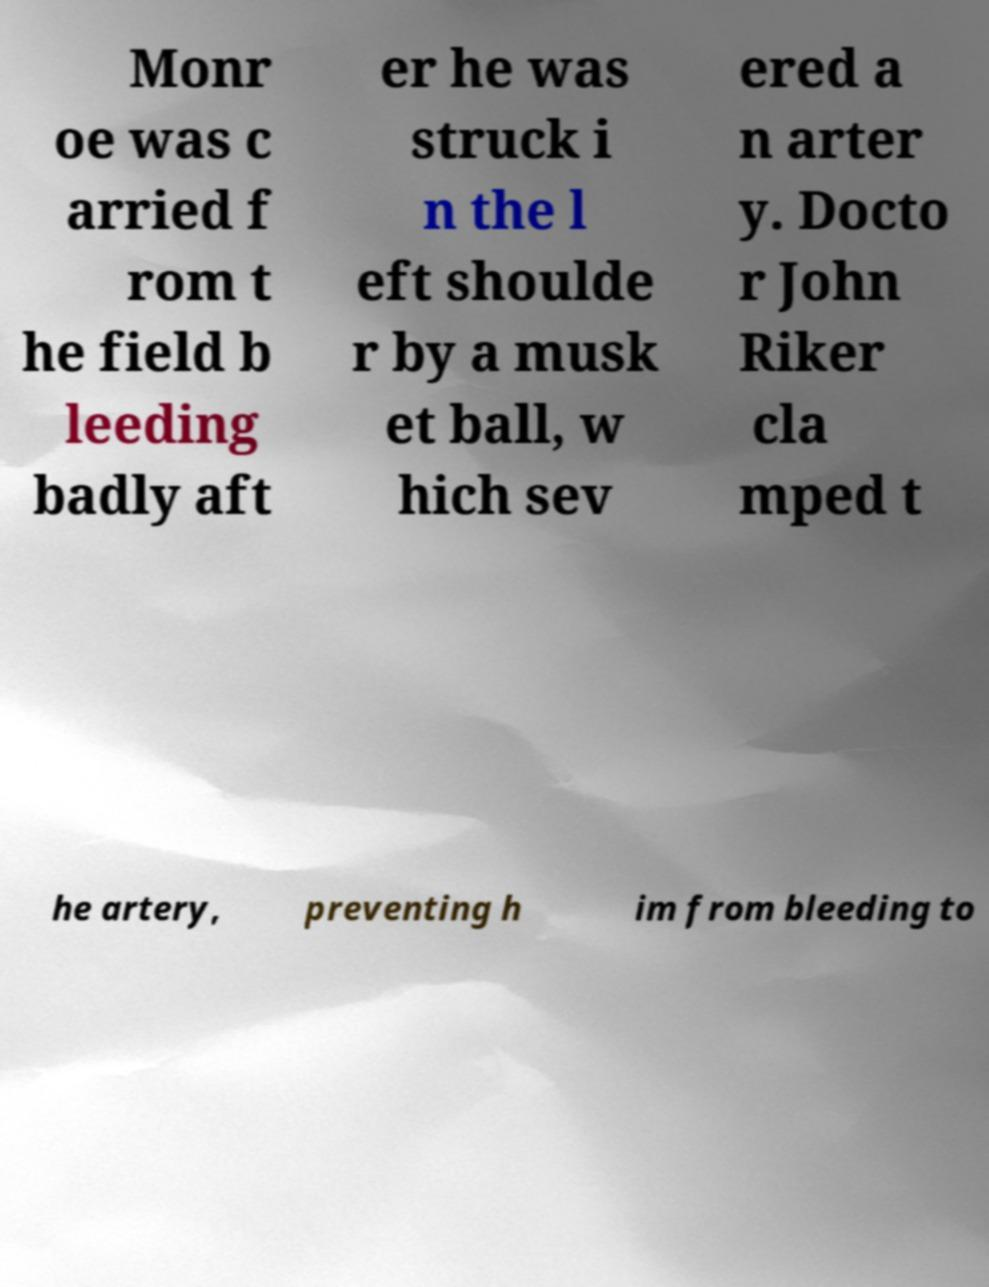There's text embedded in this image that I need extracted. Can you transcribe it verbatim? Monr oe was c arried f rom t he field b leeding badly aft er he was struck i n the l eft shoulde r by a musk et ball, w hich sev ered a n arter y. Docto r John Riker cla mped t he artery, preventing h im from bleeding to 